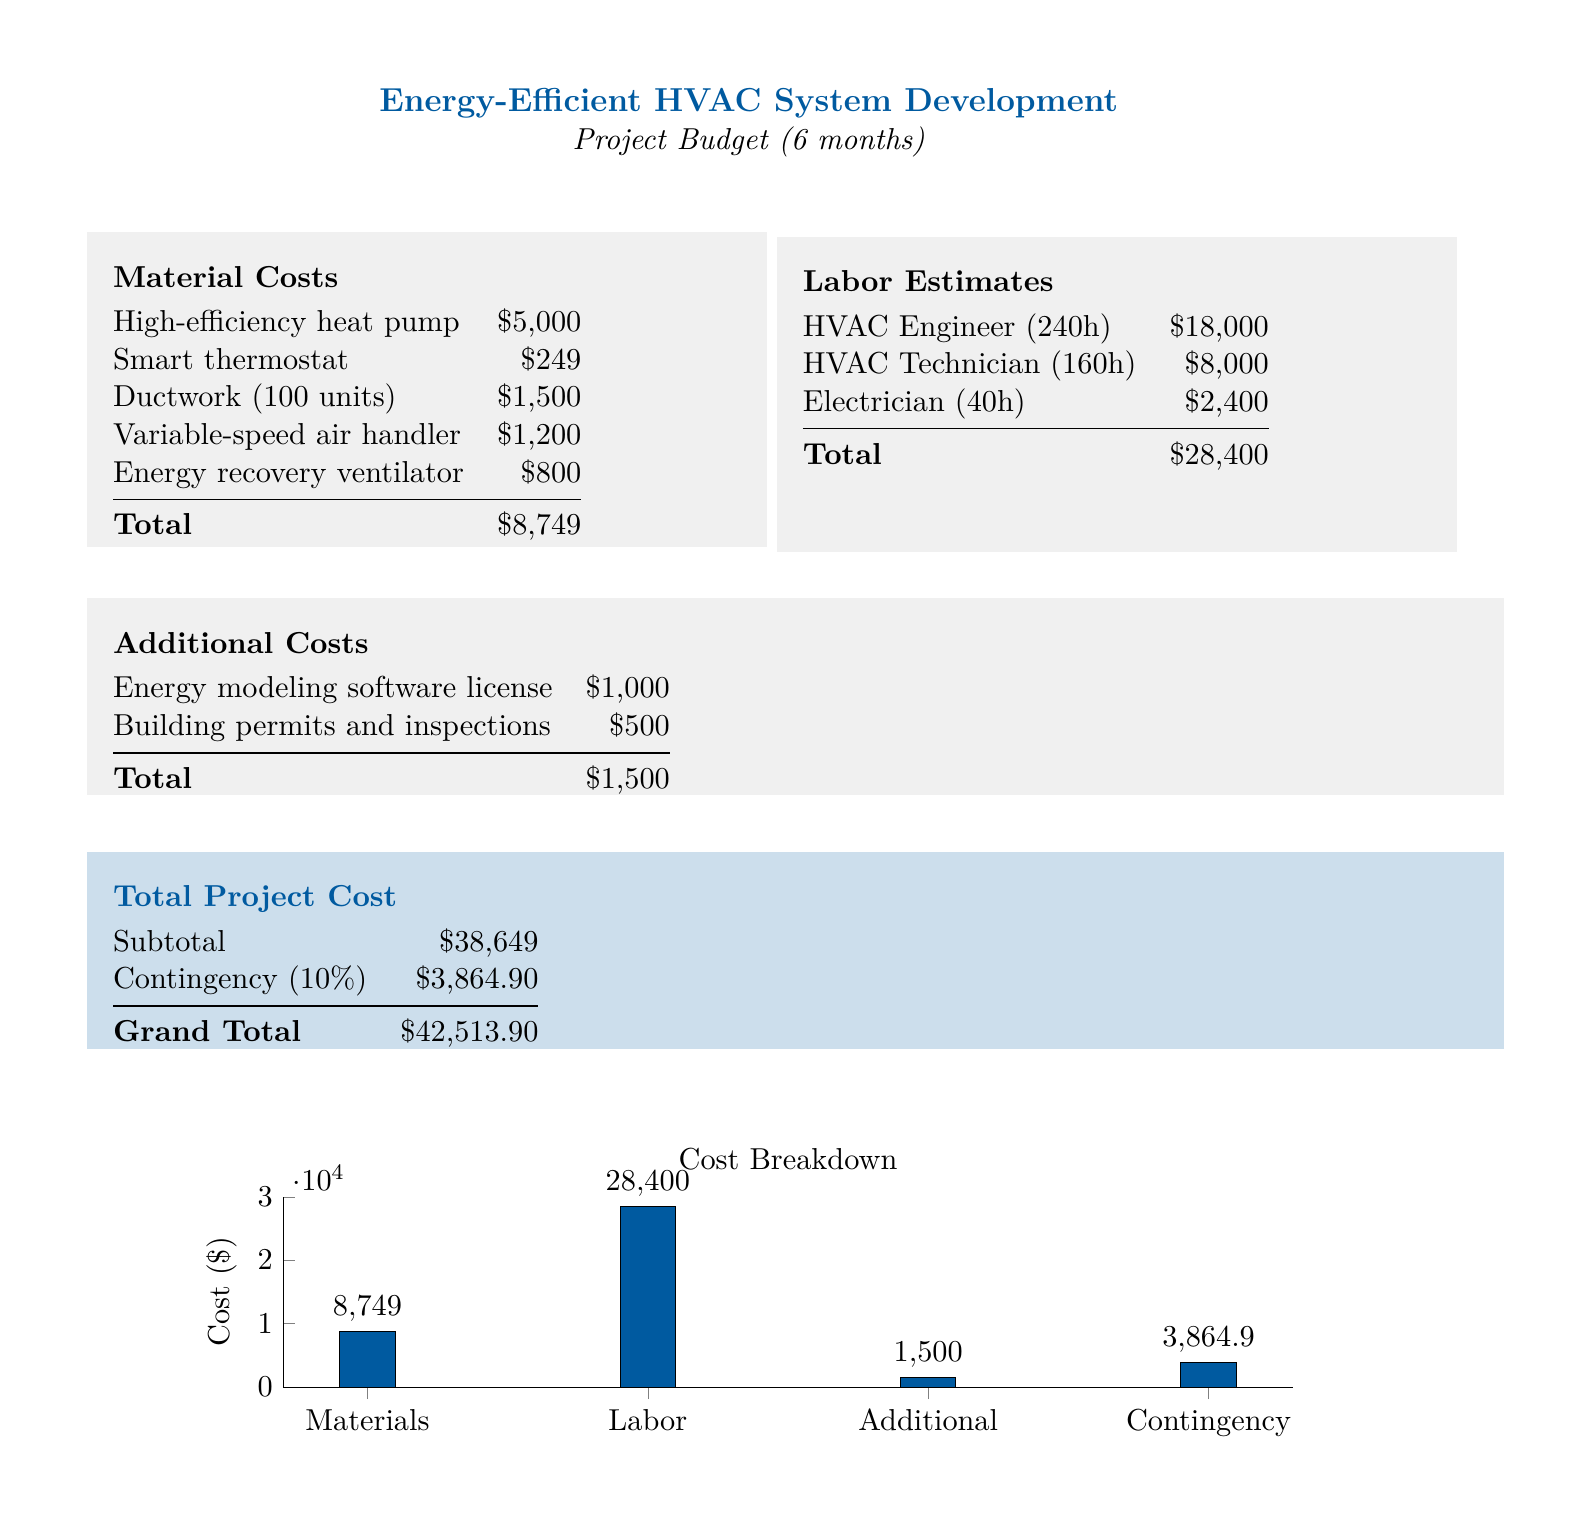what is the total material cost? The total material cost is the sum of all material expenses listed, which is $5,000 + $249 + $1,500 + $1,200 + $800 = $8,749.
Answer: $8,749 how much is the labor cost for the HVAC Engineer? The labor cost for the HVAC Engineer is specifically listed as $18,000.
Answer: $18,000 what is the total project cost before contingency? The total project cost before contingency is listed as $38,649.
Answer: $38,649 what is the contingency percentage applied to the subtotal? The contingency percentage applied to the subtotal is 10%.
Answer: 10% name one of the materials listed in the document. The document lists multiple materials; one example is the high-efficiency heat pump.
Answer: high-efficiency heat pump how many hours is the HVAC Technician estimated to work? The document specifies that the HVAC Technician is estimated to work 160 hours.
Answer: 160 hours what is the cost of the Energy Recovery Ventilator? The cost of the Energy Recovery Ventilator is $800.
Answer: $800 what is the total additional cost? The total additional cost is the sum of listed additional expenses, which is $1,000 + $500 = $1,500.
Answer: $1,500 what is the total grand cost of the project? The grand total for the project includes the subtotal and contingency, calculated as $38,649 + $3,864.90 = $42,513.90.
Answer: $42,513.90 